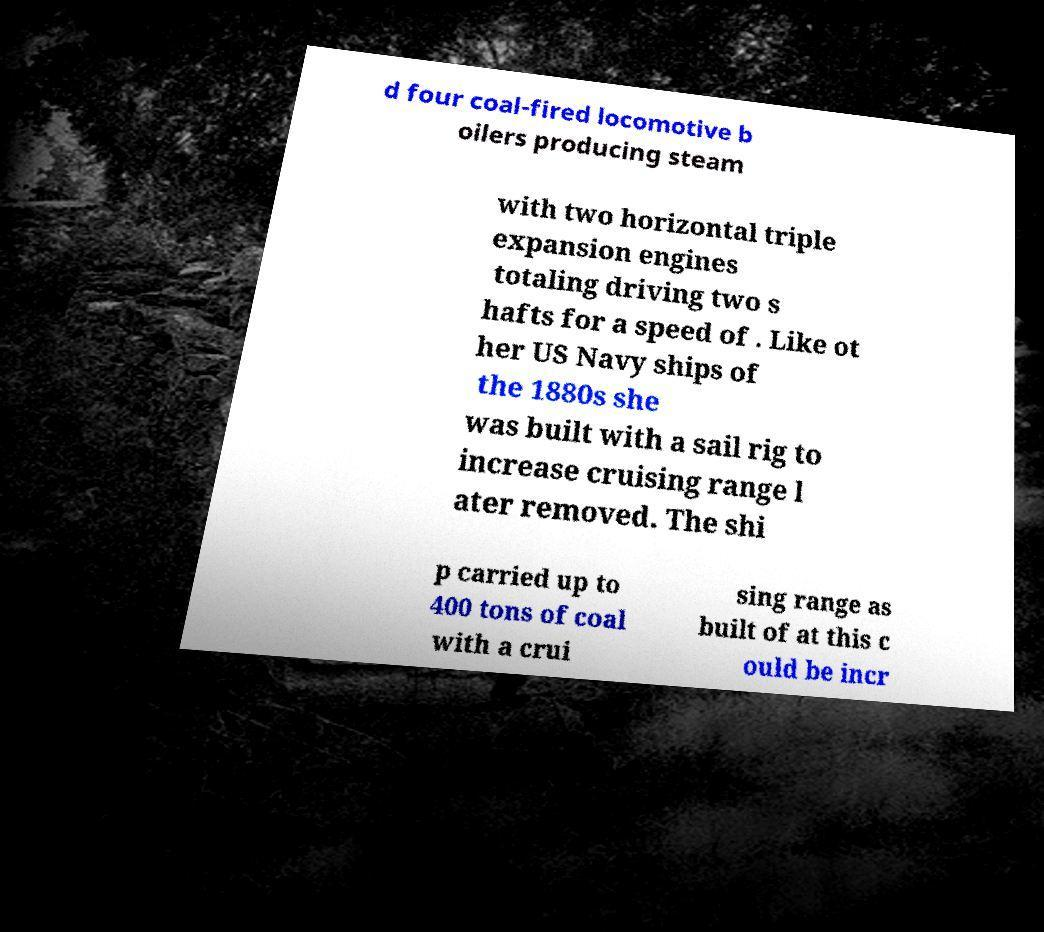What messages or text are displayed in this image? I need them in a readable, typed format. d four coal-fired locomotive b oilers producing steam with two horizontal triple expansion engines totaling driving two s hafts for a speed of . Like ot her US Navy ships of the 1880s she was built with a sail rig to increase cruising range l ater removed. The shi p carried up to 400 tons of coal with a crui sing range as built of at this c ould be incr 